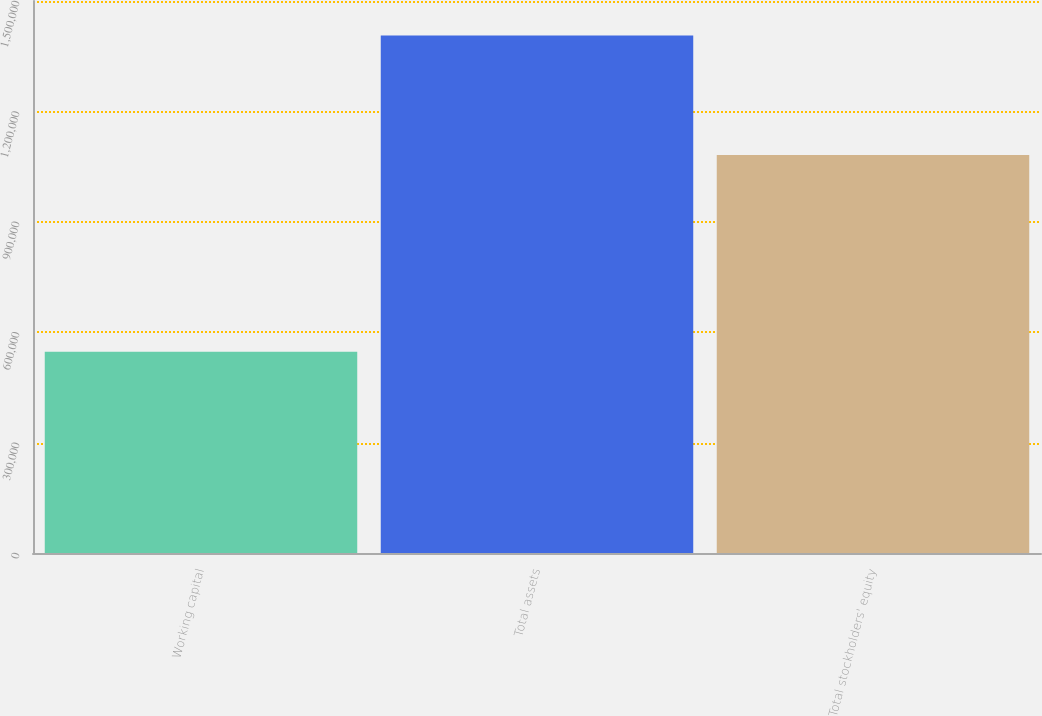Convert chart to OTSL. <chart><loc_0><loc_0><loc_500><loc_500><bar_chart><fcel>Working capital<fcel>Total assets<fcel>Total stockholders' equity<nl><fcel>546647<fcel>1.406e+06<fcel>1.08178e+06<nl></chart> 